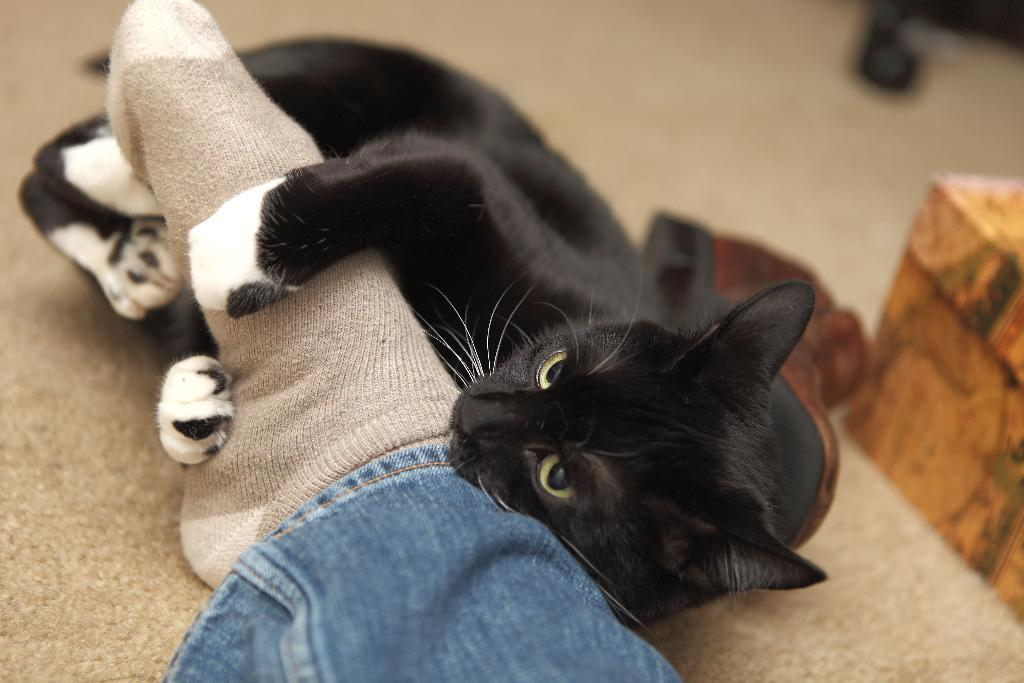What type of animal is in the image? There is a black cat in the image. What position is the cat in? The cat is lying on the floor. Can you see any part of a human in the image? Yes, there is a human leg visible in the image. How would you describe the background of the image? The background of the image is blurred. What type of berry is growing on the cat's fur in the image? There are no berries present in the image, and the cat's fur does not have any berries growing on it. 